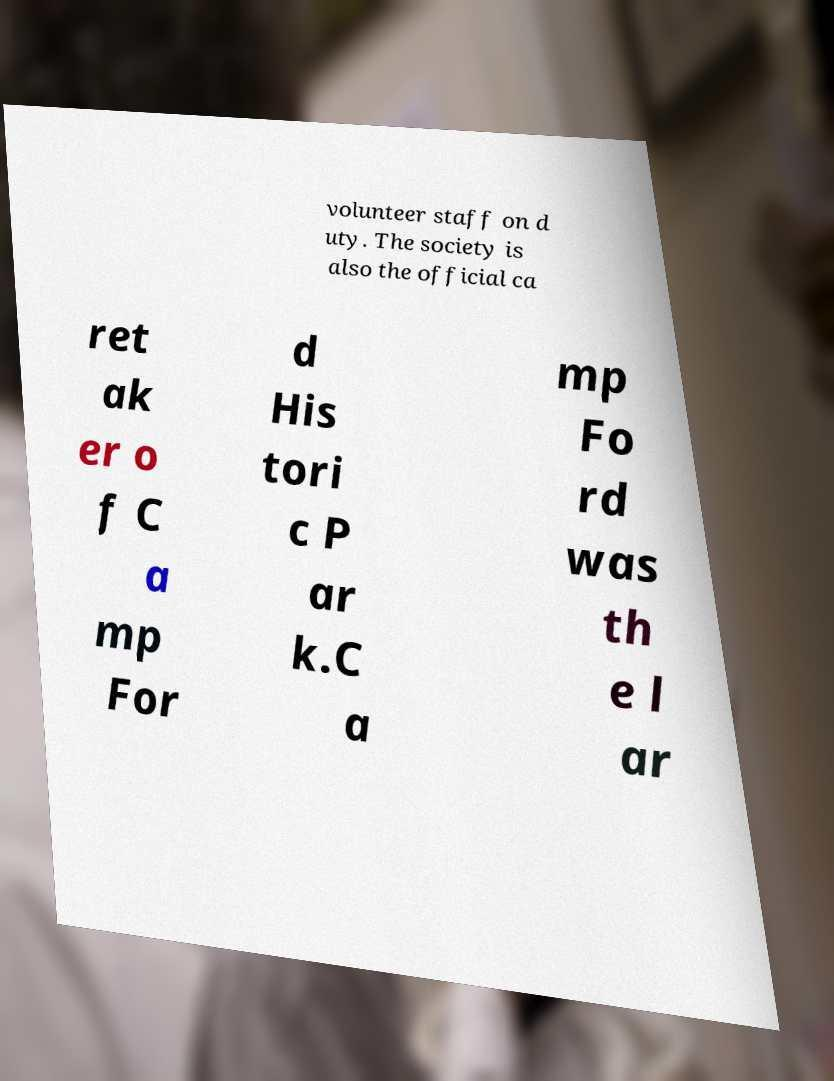Please identify and transcribe the text found in this image. volunteer staff on d uty. The society is also the official ca ret ak er o f C a mp For d His tori c P ar k.C a mp Fo rd was th e l ar 